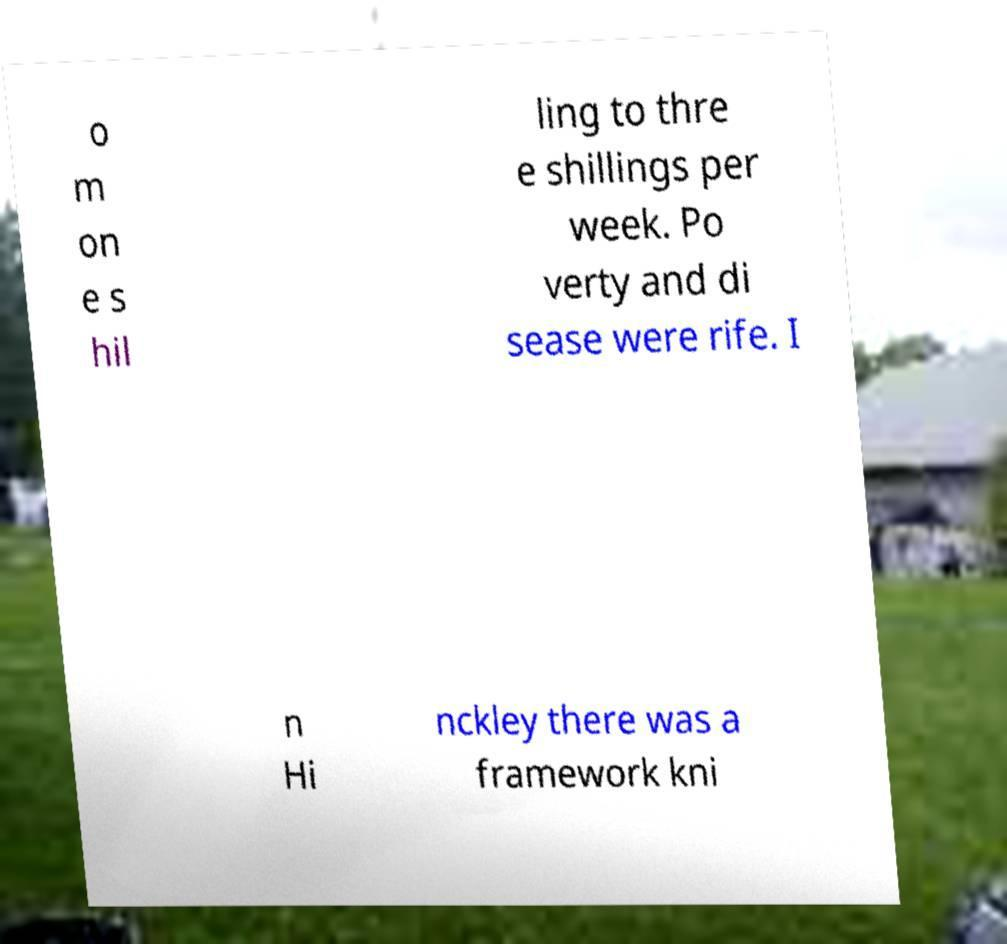What messages or text are displayed in this image? I need them in a readable, typed format. o m on e s hil ling to thre e shillings per week. Po verty and di sease were rife. I n Hi nckley there was a framework kni 